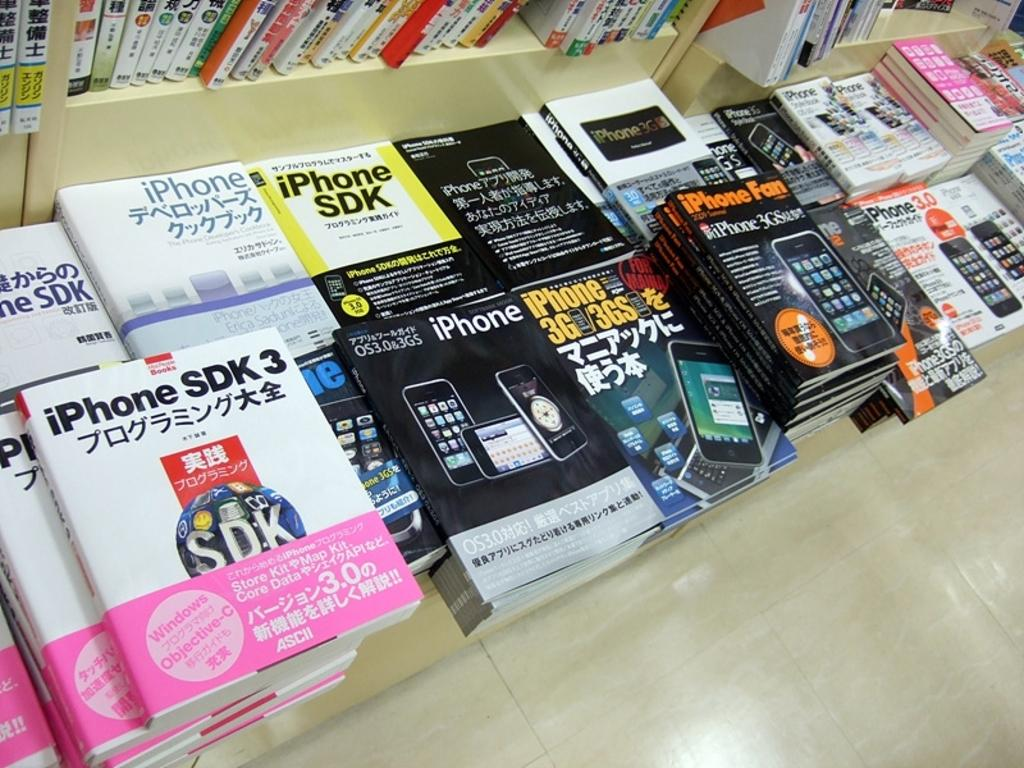Provide a one-sentence caption for the provided image. The white and pink book is titles Iphone SDK. 